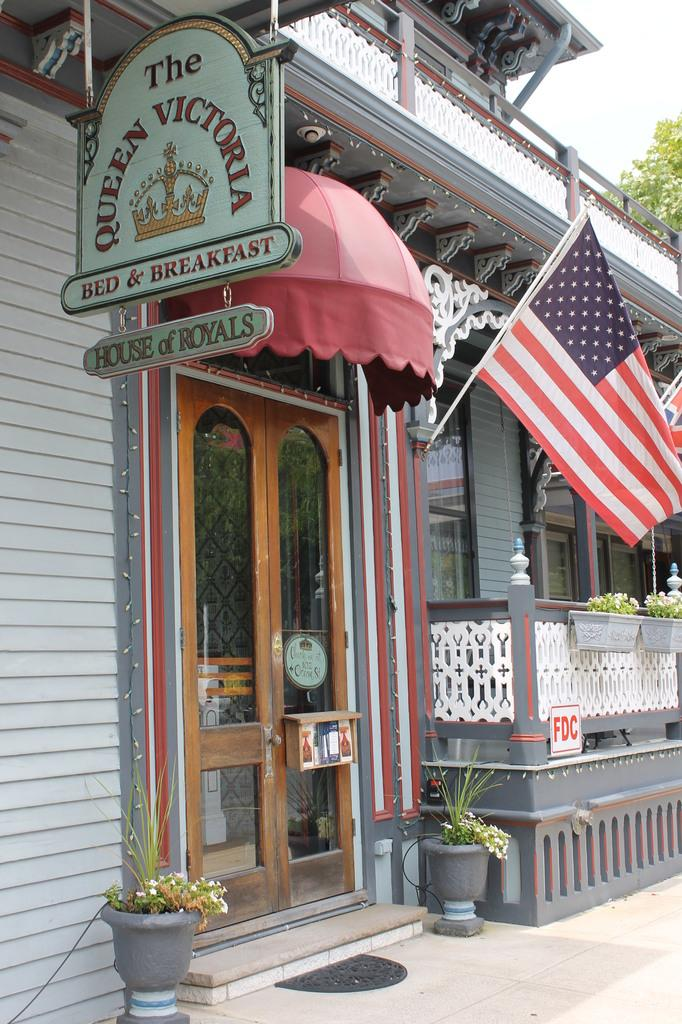<image>
Give a short and clear explanation of the subsequent image. An American flag hangs near the door of The Queen Victoria Bed and Breakfast. 